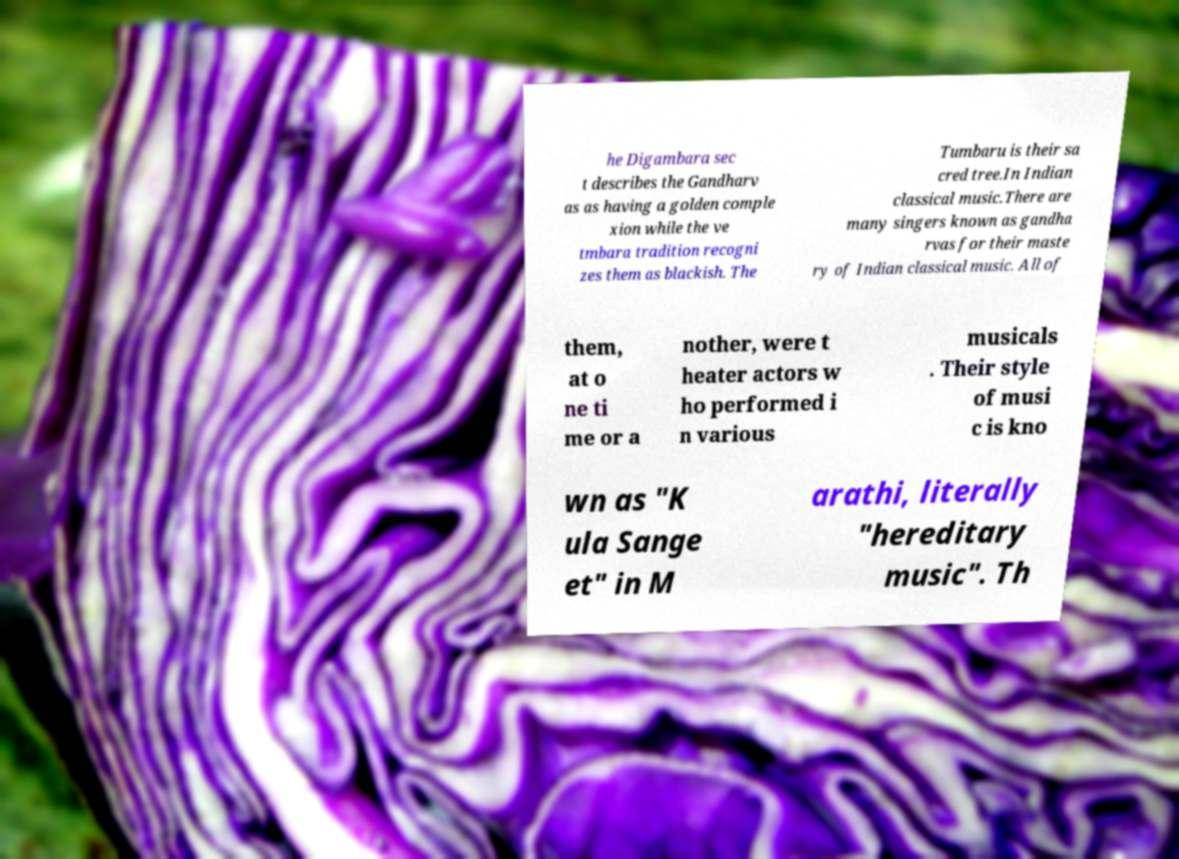For documentation purposes, I need the text within this image transcribed. Could you provide that? he Digambara sec t describes the Gandharv as as having a golden comple xion while the ve tmbara tradition recogni zes them as blackish. The Tumbaru is their sa cred tree.In Indian classical music.There are many singers known as gandha rvas for their maste ry of Indian classical music. All of them, at o ne ti me or a nother, were t heater actors w ho performed i n various musicals . Their style of musi c is kno wn as "K ula Sange et" in M arathi, literally "hereditary music". Th 